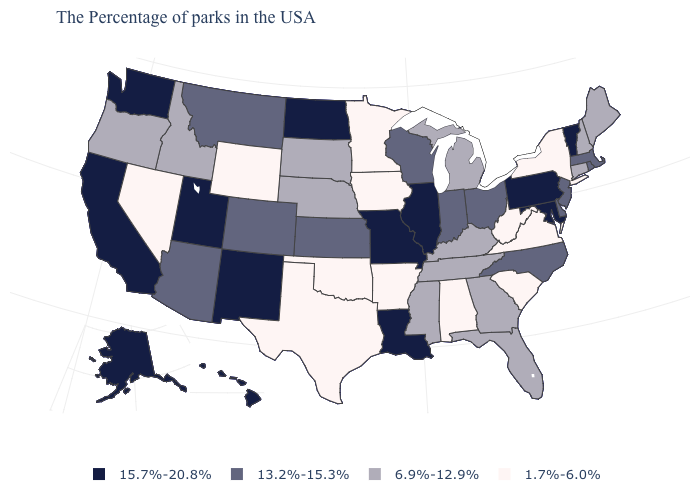What is the value of Pennsylvania?
Short answer required. 15.7%-20.8%. What is the value of California?
Write a very short answer. 15.7%-20.8%. What is the value of Arkansas?
Short answer required. 1.7%-6.0%. Does Massachusetts have the same value as Colorado?
Keep it brief. Yes. Name the states that have a value in the range 15.7%-20.8%?
Be succinct. Vermont, Maryland, Pennsylvania, Illinois, Louisiana, Missouri, North Dakota, New Mexico, Utah, California, Washington, Alaska, Hawaii. Name the states that have a value in the range 1.7%-6.0%?
Concise answer only. New York, Virginia, South Carolina, West Virginia, Alabama, Arkansas, Minnesota, Iowa, Oklahoma, Texas, Wyoming, Nevada. What is the value of Idaho?
Keep it brief. 6.9%-12.9%. What is the highest value in the West ?
Answer briefly. 15.7%-20.8%. Does Arizona have the same value as Vermont?
Give a very brief answer. No. Name the states that have a value in the range 13.2%-15.3%?
Quick response, please. Massachusetts, Rhode Island, New Jersey, Delaware, North Carolina, Ohio, Indiana, Wisconsin, Kansas, Colorado, Montana, Arizona. Name the states that have a value in the range 1.7%-6.0%?
Quick response, please. New York, Virginia, South Carolina, West Virginia, Alabama, Arkansas, Minnesota, Iowa, Oklahoma, Texas, Wyoming, Nevada. What is the value of Kansas?
Quick response, please. 13.2%-15.3%. Name the states that have a value in the range 13.2%-15.3%?
Keep it brief. Massachusetts, Rhode Island, New Jersey, Delaware, North Carolina, Ohio, Indiana, Wisconsin, Kansas, Colorado, Montana, Arizona. What is the value of North Dakota?
Give a very brief answer. 15.7%-20.8%. 